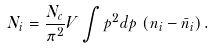Convert formula to latex. <formula><loc_0><loc_0><loc_500><loc_500>N _ { i } = \frac { N _ { c } } { \pi ^ { 2 } } V \int p ^ { 2 } d p \, \left ( n _ { i } - \bar { n } _ { i } \right ) .</formula> 